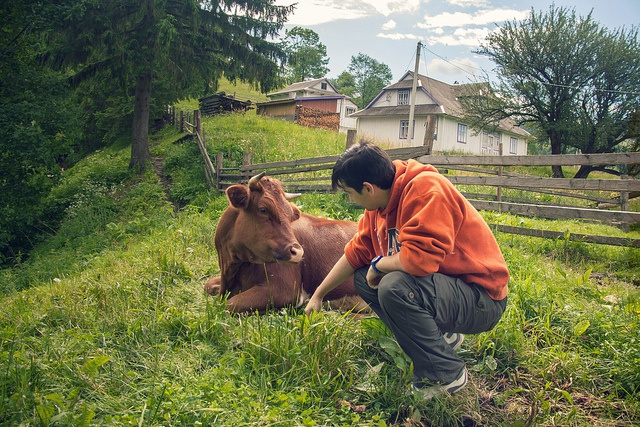Describe the objects in this image and their specific colors. I can see people in black, gray, salmon, and maroon tones and cow in black, maroon, and brown tones in this image. 